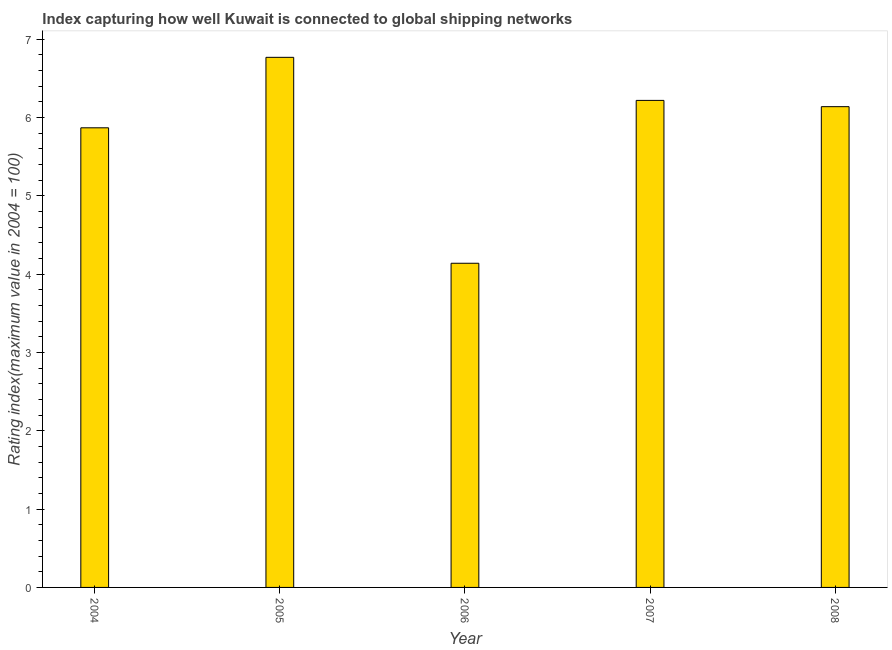Does the graph contain grids?
Give a very brief answer. No. What is the title of the graph?
Your answer should be very brief. Index capturing how well Kuwait is connected to global shipping networks. What is the label or title of the Y-axis?
Make the answer very short. Rating index(maximum value in 2004 = 100). What is the liner shipping connectivity index in 2007?
Make the answer very short. 6.22. Across all years, what is the maximum liner shipping connectivity index?
Offer a terse response. 6.77. Across all years, what is the minimum liner shipping connectivity index?
Make the answer very short. 4.14. In which year was the liner shipping connectivity index maximum?
Keep it short and to the point. 2005. What is the sum of the liner shipping connectivity index?
Provide a succinct answer. 29.14. What is the difference between the liner shipping connectivity index in 2004 and 2005?
Offer a very short reply. -0.9. What is the average liner shipping connectivity index per year?
Provide a short and direct response. 5.83. What is the median liner shipping connectivity index?
Give a very brief answer. 6.14. What is the ratio of the liner shipping connectivity index in 2005 to that in 2006?
Ensure brevity in your answer.  1.64. Is the liner shipping connectivity index in 2006 less than that in 2008?
Provide a short and direct response. Yes. Is the difference between the liner shipping connectivity index in 2006 and 2007 greater than the difference between any two years?
Provide a short and direct response. No. What is the difference between the highest and the second highest liner shipping connectivity index?
Offer a very short reply. 0.55. What is the difference between the highest and the lowest liner shipping connectivity index?
Keep it short and to the point. 2.63. How many bars are there?
Keep it short and to the point. 5. How many years are there in the graph?
Provide a short and direct response. 5. What is the difference between two consecutive major ticks on the Y-axis?
Keep it short and to the point. 1. What is the Rating index(maximum value in 2004 = 100) of 2004?
Provide a succinct answer. 5.87. What is the Rating index(maximum value in 2004 = 100) of 2005?
Offer a terse response. 6.77. What is the Rating index(maximum value in 2004 = 100) in 2006?
Offer a terse response. 4.14. What is the Rating index(maximum value in 2004 = 100) in 2007?
Ensure brevity in your answer.  6.22. What is the Rating index(maximum value in 2004 = 100) in 2008?
Your answer should be compact. 6.14. What is the difference between the Rating index(maximum value in 2004 = 100) in 2004 and 2006?
Offer a very short reply. 1.73. What is the difference between the Rating index(maximum value in 2004 = 100) in 2004 and 2007?
Your answer should be compact. -0.35. What is the difference between the Rating index(maximum value in 2004 = 100) in 2004 and 2008?
Offer a very short reply. -0.27. What is the difference between the Rating index(maximum value in 2004 = 100) in 2005 and 2006?
Offer a very short reply. 2.63. What is the difference between the Rating index(maximum value in 2004 = 100) in 2005 and 2007?
Your answer should be compact. 0.55. What is the difference between the Rating index(maximum value in 2004 = 100) in 2005 and 2008?
Make the answer very short. 0.63. What is the difference between the Rating index(maximum value in 2004 = 100) in 2006 and 2007?
Give a very brief answer. -2.08. What is the difference between the Rating index(maximum value in 2004 = 100) in 2006 and 2008?
Your response must be concise. -2. What is the difference between the Rating index(maximum value in 2004 = 100) in 2007 and 2008?
Provide a short and direct response. 0.08. What is the ratio of the Rating index(maximum value in 2004 = 100) in 2004 to that in 2005?
Your answer should be very brief. 0.87. What is the ratio of the Rating index(maximum value in 2004 = 100) in 2004 to that in 2006?
Give a very brief answer. 1.42. What is the ratio of the Rating index(maximum value in 2004 = 100) in 2004 to that in 2007?
Your answer should be compact. 0.94. What is the ratio of the Rating index(maximum value in 2004 = 100) in 2004 to that in 2008?
Your response must be concise. 0.96. What is the ratio of the Rating index(maximum value in 2004 = 100) in 2005 to that in 2006?
Provide a succinct answer. 1.64. What is the ratio of the Rating index(maximum value in 2004 = 100) in 2005 to that in 2007?
Your answer should be compact. 1.09. What is the ratio of the Rating index(maximum value in 2004 = 100) in 2005 to that in 2008?
Offer a terse response. 1.1. What is the ratio of the Rating index(maximum value in 2004 = 100) in 2006 to that in 2007?
Your answer should be compact. 0.67. What is the ratio of the Rating index(maximum value in 2004 = 100) in 2006 to that in 2008?
Offer a very short reply. 0.67. What is the ratio of the Rating index(maximum value in 2004 = 100) in 2007 to that in 2008?
Your response must be concise. 1.01. 